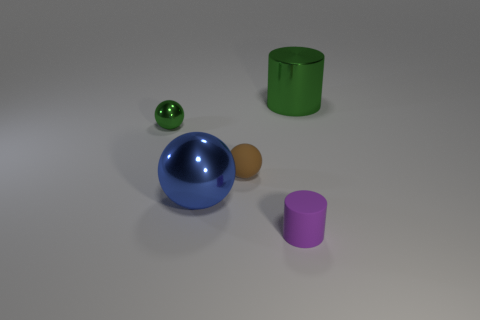Subtract 1 balls. How many balls are left? 2 Subtract all small spheres. How many spheres are left? 1 Add 5 blue spheres. How many objects exist? 10 Subtract all cylinders. How many objects are left? 3 Add 1 big green cylinders. How many big green cylinders exist? 2 Subtract 0 blue cylinders. How many objects are left? 5 Subtract all tiny rubber objects. Subtract all small brown balls. How many objects are left? 2 Add 5 purple things. How many purple things are left? 6 